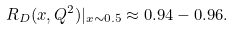<formula> <loc_0><loc_0><loc_500><loc_500>R _ { D } ( x , Q ^ { 2 } ) | _ { x \sim 0 . 5 } \approx 0 . 9 4 - 0 . 9 6 .</formula> 